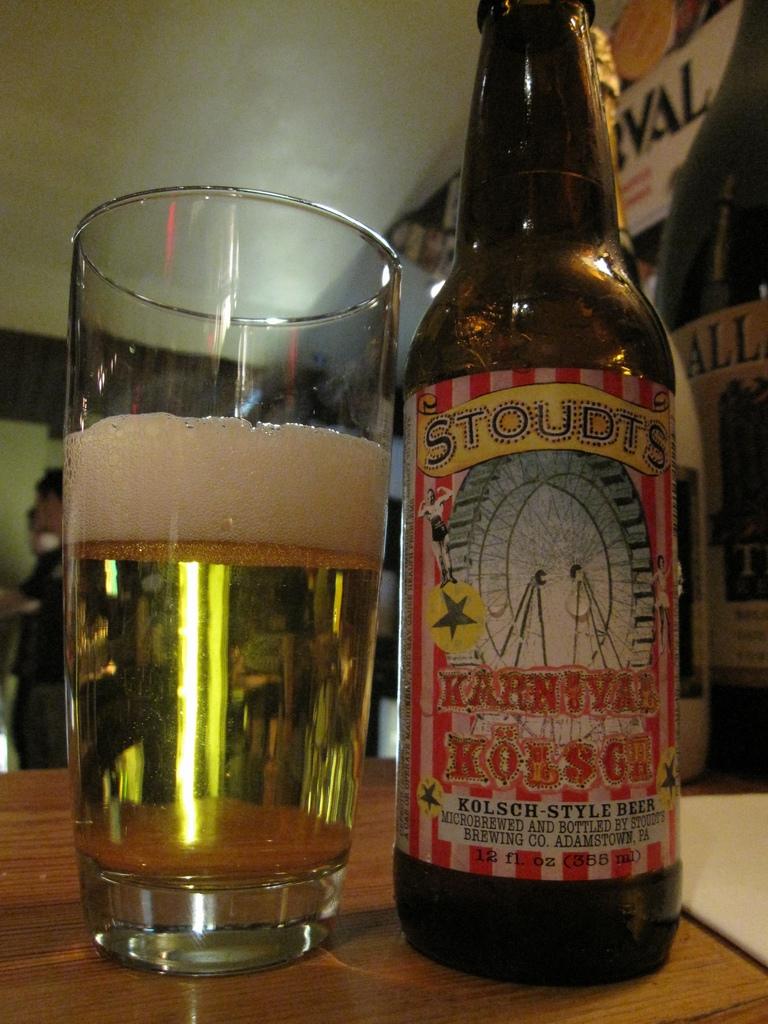What brand of beer is this?
Your answer should be compact. Stoudts. 